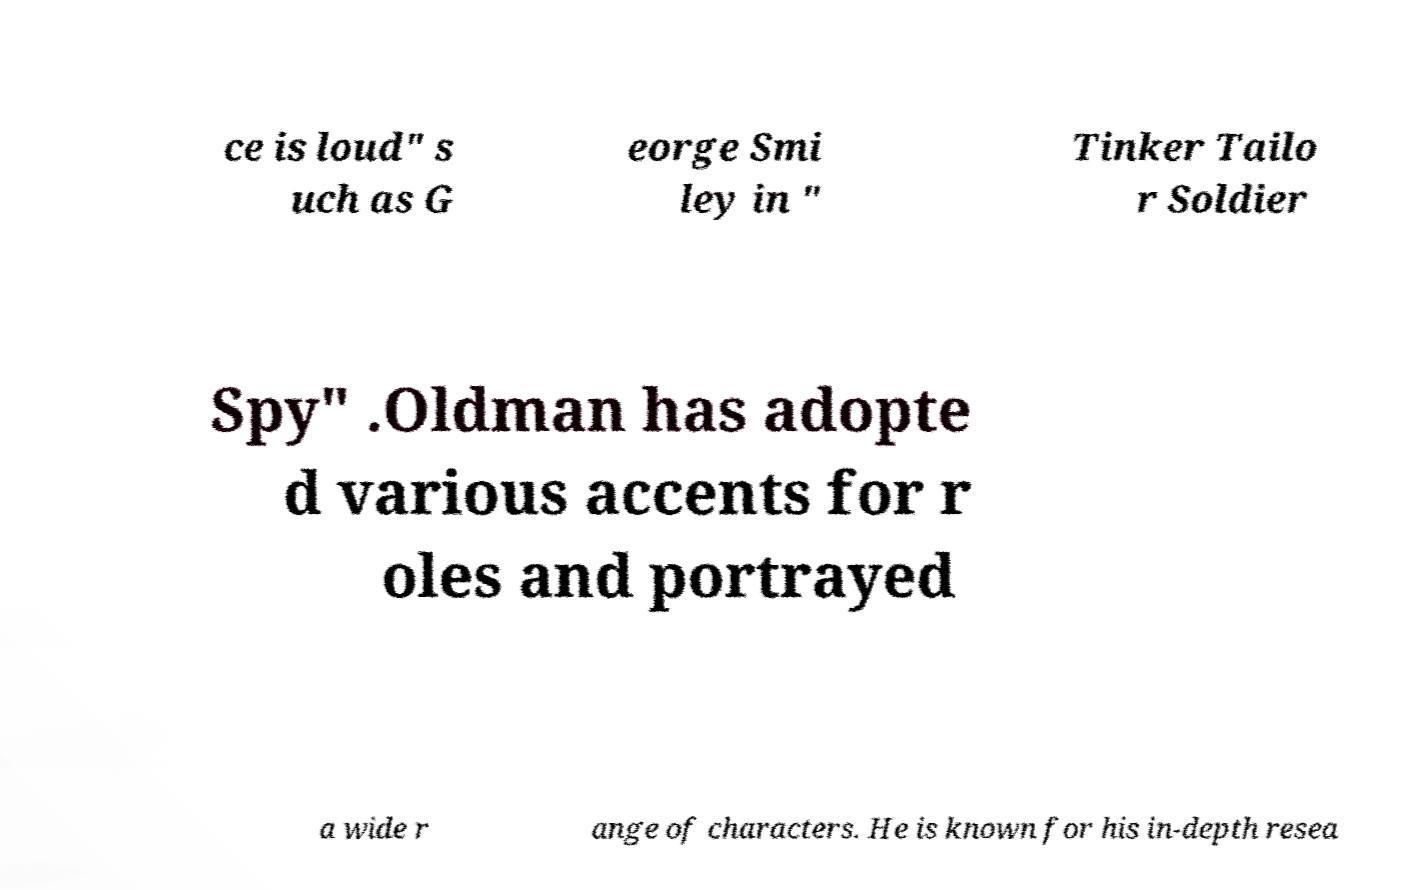Please identify and transcribe the text found in this image. ce is loud" s uch as G eorge Smi ley in " Tinker Tailo r Soldier Spy" .Oldman has adopte d various accents for r oles and portrayed a wide r ange of characters. He is known for his in-depth resea 